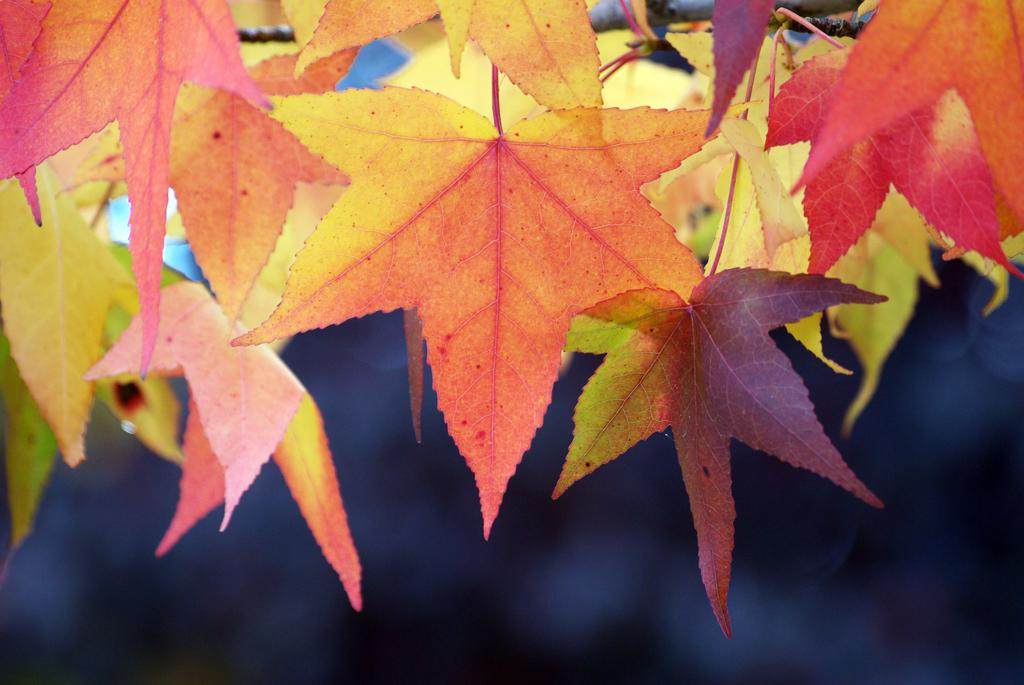What type of vegetation is present in the image? There are leaves in the image. What color are the leaves? The leaves are in orange color. What color is visible at the bottom of the image? There is black color visible at the bottom of the image. Can you see a wren perched on the leaves in the image? There is no wren present in the image; it only features leaves in orange color. Are there any beetles crawling on the leaves in the image? There are no beetles visible on the leaves in the image. 